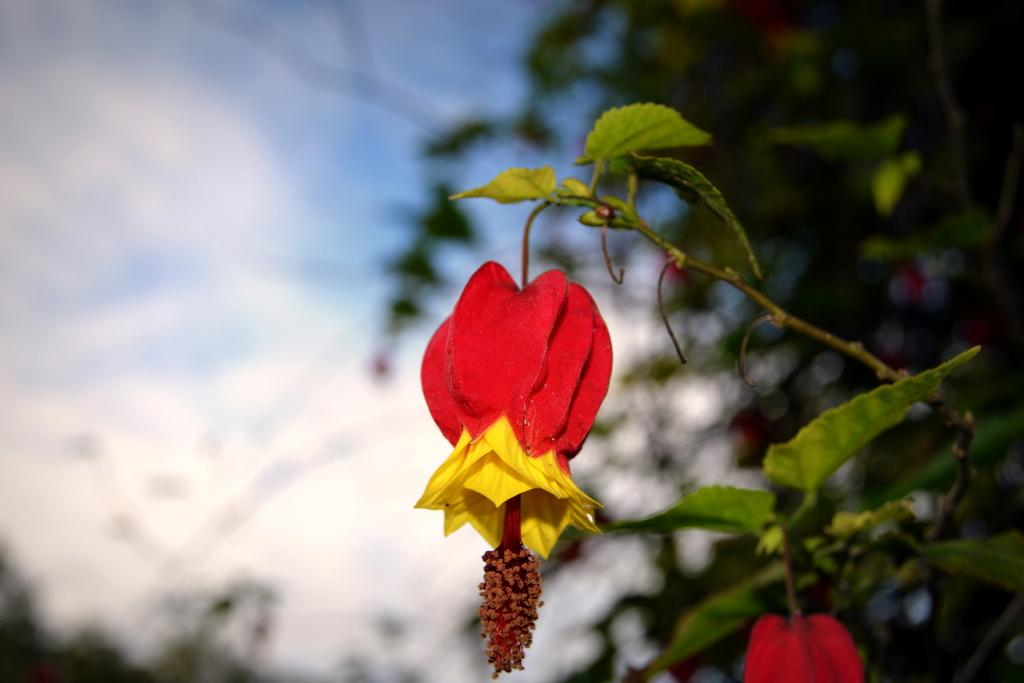What color are the flowers in the image? The flowers in the image are red. What else can be seen in the background of the image? There are plants in the background of the image. How is the background of the image depicted? The background of the image is blurred. What type of weather can be seen in the image? There is no indication of weather in the image, as it focuses on the flowers and plants. 